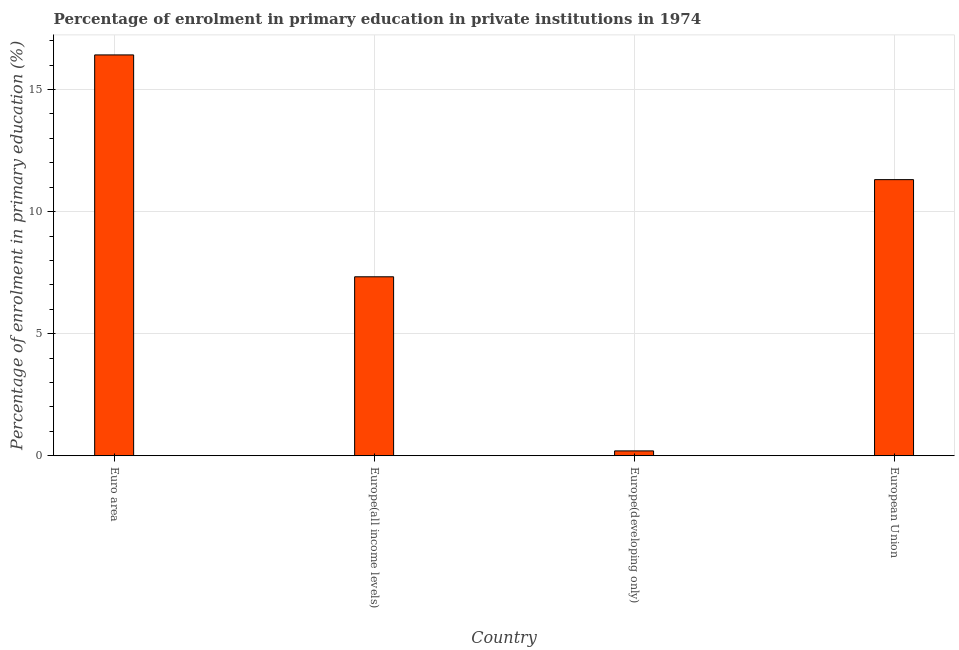Does the graph contain any zero values?
Make the answer very short. No. What is the title of the graph?
Offer a very short reply. Percentage of enrolment in primary education in private institutions in 1974. What is the label or title of the X-axis?
Ensure brevity in your answer.  Country. What is the label or title of the Y-axis?
Your answer should be very brief. Percentage of enrolment in primary education (%). What is the enrolment percentage in primary education in European Union?
Ensure brevity in your answer.  11.31. Across all countries, what is the maximum enrolment percentage in primary education?
Offer a very short reply. 16.42. Across all countries, what is the minimum enrolment percentage in primary education?
Provide a succinct answer. 0.2. In which country was the enrolment percentage in primary education maximum?
Your response must be concise. Euro area. In which country was the enrolment percentage in primary education minimum?
Your answer should be very brief. Europe(developing only). What is the sum of the enrolment percentage in primary education?
Provide a short and direct response. 35.26. What is the difference between the enrolment percentage in primary education in Europe(all income levels) and European Union?
Your answer should be very brief. -3.98. What is the average enrolment percentage in primary education per country?
Provide a succinct answer. 8.81. What is the median enrolment percentage in primary education?
Offer a terse response. 9.32. In how many countries, is the enrolment percentage in primary education greater than 10 %?
Ensure brevity in your answer.  2. What is the ratio of the enrolment percentage in primary education in Europe(developing only) to that in European Union?
Ensure brevity in your answer.  0.02. Is the enrolment percentage in primary education in Euro area less than that in Europe(all income levels)?
Offer a very short reply. No. Is the difference between the enrolment percentage in primary education in Europe(developing only) and European Union greater than the difference between any two countries?
Your response must be concise. No. What is the difference between the highest and the second highest enrolment percentage in primary education?
Give a very brief answer. 5.11. What is the difference between the highest and the lowest enrolment percentage in primary education?
Offer a very short reply. 16.22. How many bars are there?
Keep it short and to the point. 4. How many countries are there in the graph?
Your answer should be compact. 4. What is the difference between two consecutive major ticks on the Y-axis?
Your answer should be very brief. 5. Are the values on the major ticks of Y-axis written in scientific E-notation?
Give a very brief answer. No. What is the Percentage of enrolment in primary education (%) in Euro area?
Give a very brief answer. 16.42. What is the Percentage of enrolment in primary education (%) of Europe(all income levels)?
Your answer should be compact. 7.33. What is the Percentage of enrolment in primary education (%) of Europe(developing only)?
Offer a very short reply. 0.2. What is the Percentage of enrolment in primary education (%) in European Union?
Your answer should be very brief. 11.31. What is the difference between the Percentage of enrolment in primary education (%) in Euro area and Europe(all income levels)?
Your response must be concise. 9.09. What is the difference between the Percentage of enrolment in primary education (%) in Euro area and Europe(developing only)?
Your answer should be very brief. 16.22. What is the difference between the Percentage of enrolment in primary education (%) in Euro area and European Union?
Provide a short and direct response. 5.11. What is the difference between the Percentage of enrolment in primary education (%) in Europe(all income levels) and Europe(developing only)?
Offer a terse response. 7.13. What is the difference between the Percentage of enrolment in primary education (%) in Europe(all income levels) and European Union?
Your response must be concise. -3.98. What is the difference between the Percentage of enrolment in primary education (%) in Europe(developing only) and European Union?
Provide a short and direct response. -11.11. What is the ratio of the Percentage of enrolment in primary education (%) in Euro area to that in Europe(all income levels)?
Offer a very short reply. 2.24. What is the ratio of the Percentage of enrolment in primary education (%) in Euro area to that in Europe(developing only)?
Your answer should be very brief. 82.97. What is the ratio of the Percentage of enrolment in primary education (%) in Euro area to that in European Union?
Keep it short and to the point. 1.45. What is the ratio of the Percentage of enrolment in primary education (%) in Europe(all income levels) to that in Europe(developing only)?
Your response must be concise. 37.04. What is the ratio of the Percentage of enrolment in primary education (%) in Europe(all income levels) to that in European Union?
Offer a very short reply. 0.65. What is the ratio of the Percentage of enrolment in primary education (%) in Europe(developing only) to that in European Union?
Offer a very short reply. 0.02. 